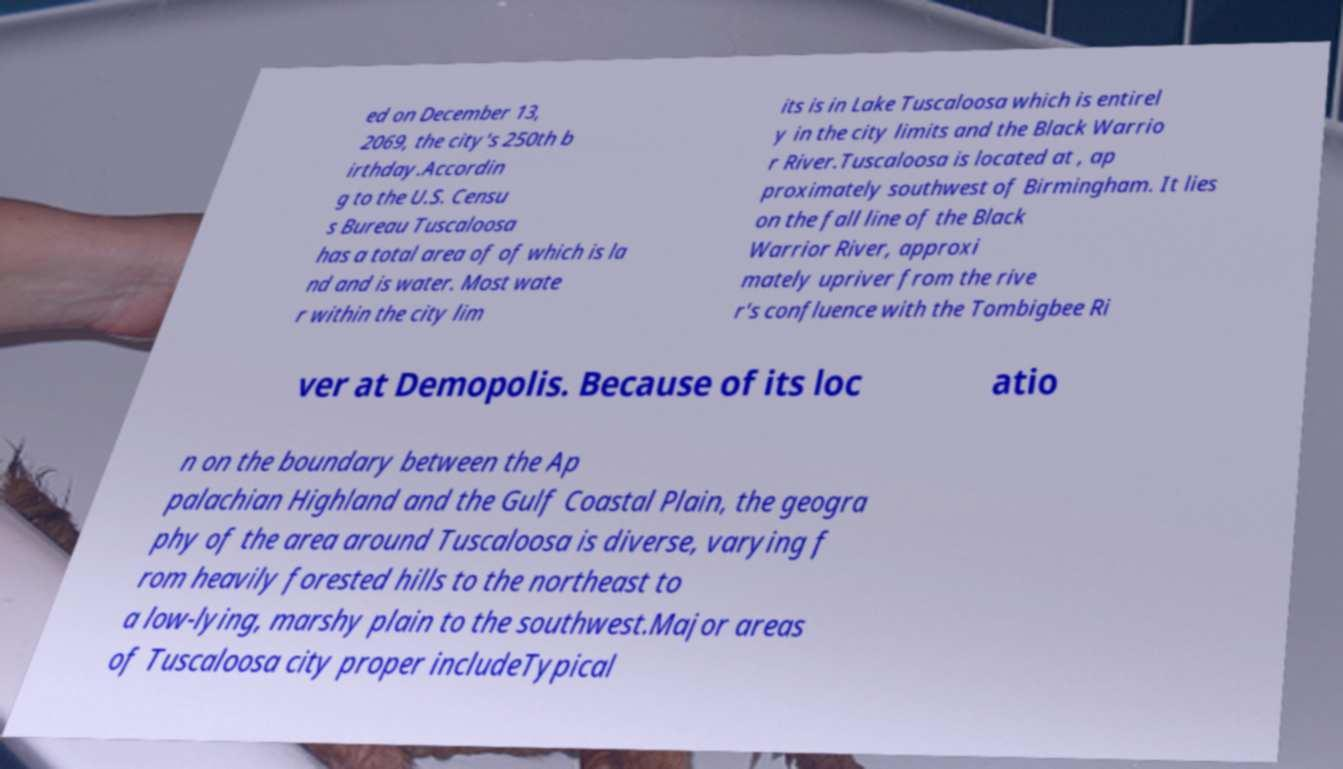What messages or text are displayed in this image? I need them in a readable, typed format. ed on December 13, 2069, the city's 250th b irthday.Accordin g to the U.S. Censu s Bureau Tuscaloosa has a total area of of which is la nd and is water. Most wate r within the city lim its is in Lake Tuscaloosa which is entirel y in the city limits and the Black Warrio r River.Tuscaloosa is located at , ap proximately southwest of Birmingham. It lies on the fall line of the Black Warrior River, approxi mately upriver from the rive r's confluence with the Tombigbee Ri ver at Demopolis. Because of its loc atio n on the boundary between the Ap palachian Highland and the Gulf Coastal Plain, the geogra phy of the area around Tuscaloosa is diverse, varying f rom heavily forested hills to the northeast to a low-lying, marshy plain to the southwest.Major areas of Tuscaloosa city proper includeTypical 